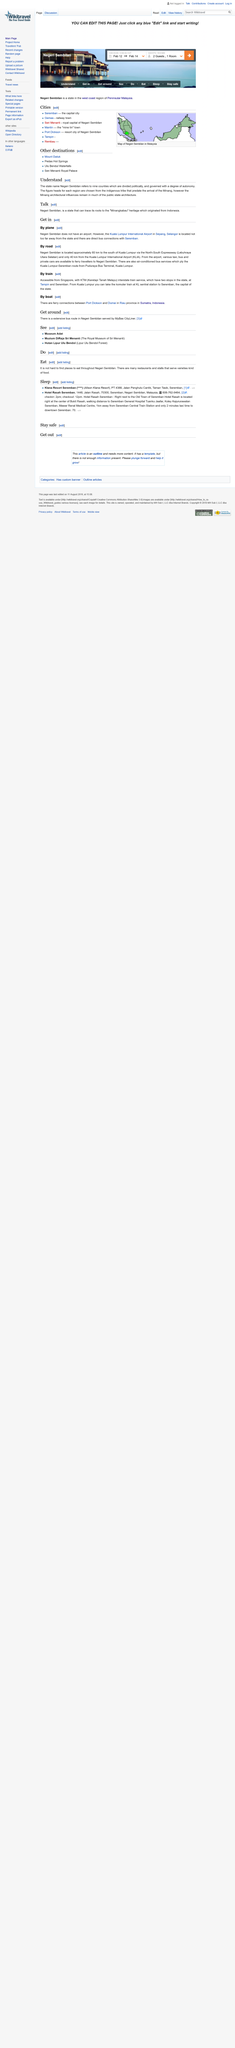Point out several critical features in this image. There are two places of lodging in Seremban, which are Klana Resort and Hotel Rasah. Yes, the Hotel Rasah in Seremban is within walking distance to Seremban General Hospital. The nine counties are politically divided. Yes, the state that references nine counties can trace its roots to the Minangkabau heritage. Dumai has ferry connectivity with Port Dickson. 